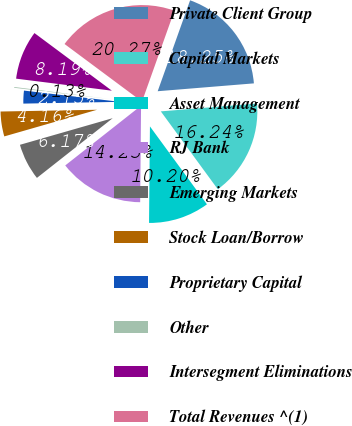Convert chart. <chart><loc_0><loc_0><loc_500><loc_500><pie_chart><fcel>Private Client Group<fcel>Capital Markets<fcel>Asset Management<fcel>RJ Bank<fcel>Emerging Markets<fcel>Stock Loan/Borrow<fcel>Proprietary Capital<fcel>Other<fcel>Intersegment Eliminations<fcel>Total Revenues ^(1)<nl><fcel>18.25%<fcel>16.24%<fcel>10.2%<fcel>14.23%<fcel>6.17%<fcel>4.16%<fcel>2.15%<fcel>0.13%<fcel>8.19%<fcel>20.27%<nl></chart> 